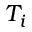<formula> <loc_0><loc_0><loc_500><loc_500>T _ { i }</formula> 